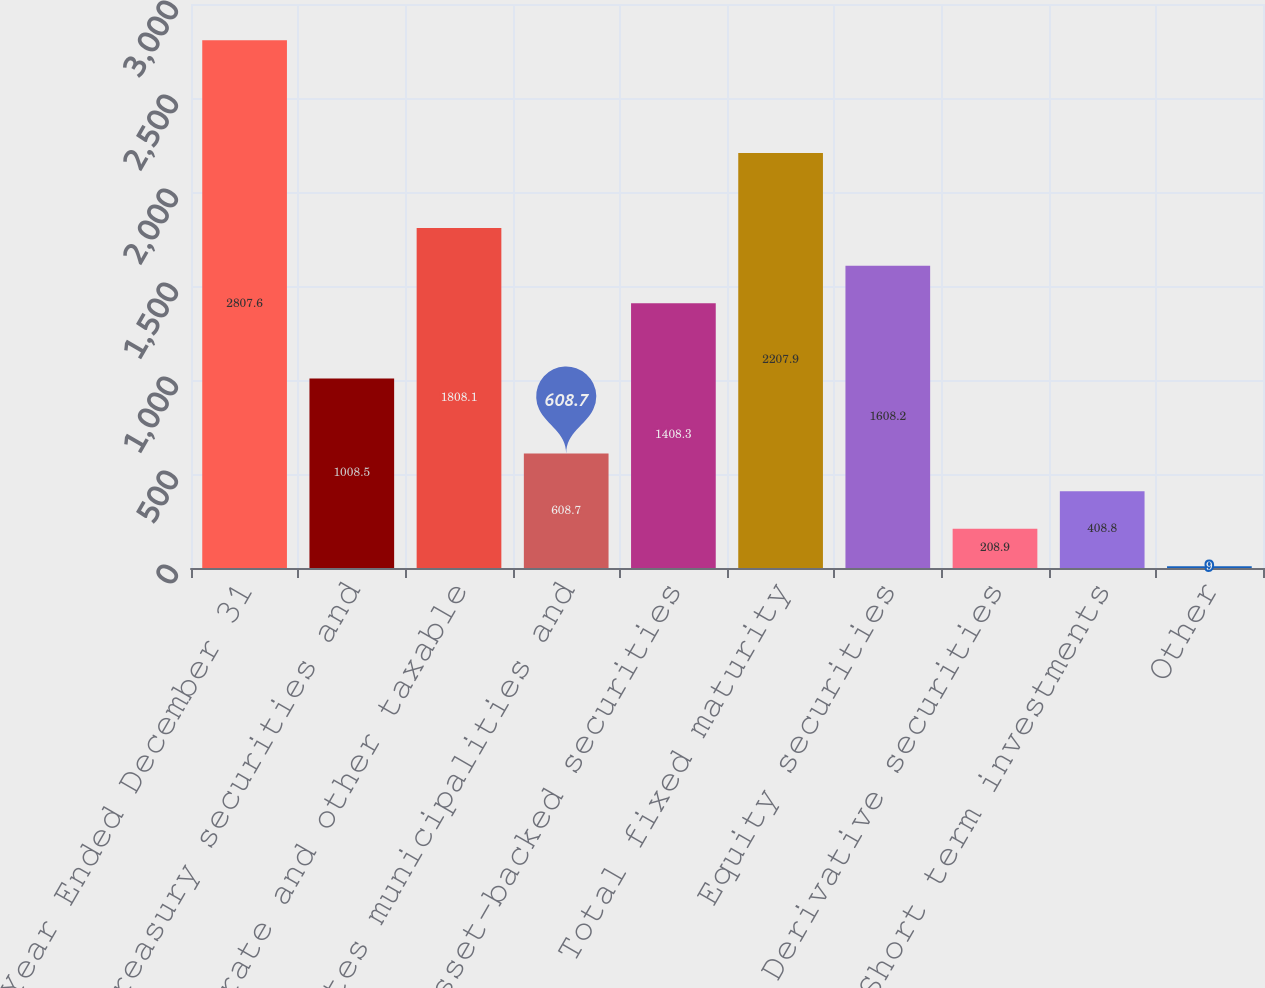Convert chart. <chart><loc_0><loc_0><loc_500><loc_500><bar_chart><fcel>Year Ended December 31<fcel>US Treasury securities and<fcel>Corporate and other taxable<fcel>States municipalities and<fcel>Asset-backed securities<fcel>Total fixed maturity<fcel>Equity securities<fcel>Derivative securities<fcel>Short term investments<fcel>Other<nl><fcel>2807.6<fcel>1008.5<fcel>1808.1<fcel>608.7<fcel>1408.3<fcel>2207.9<fcel>1608.2<fcel>208.9<fcel>408.8<fcel>9<nl></chart> 